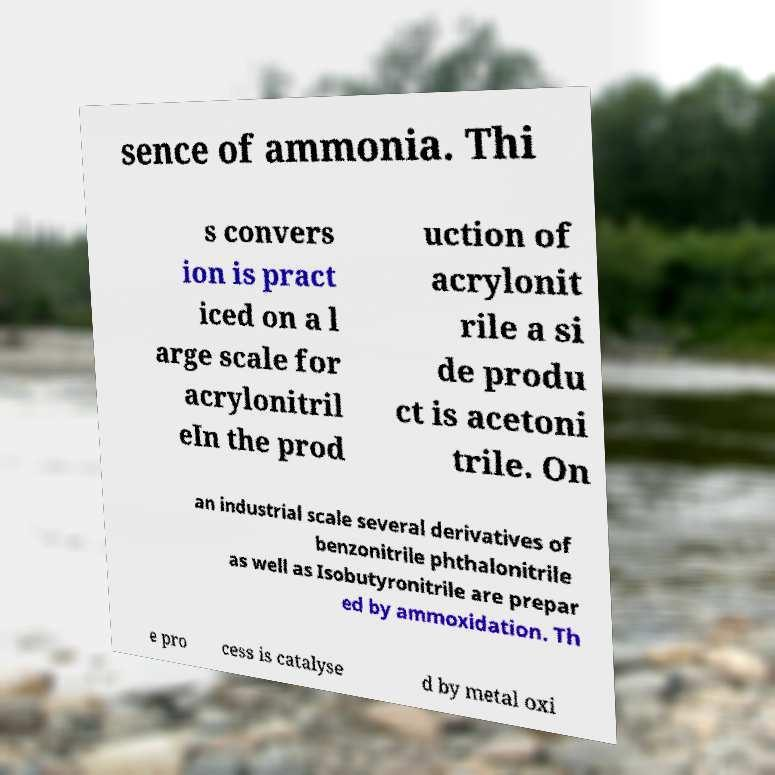Please read and relay the text visible in this image. What does it say? sence of ammonia. Thi s convers ion is pract iced on a l arge scale for acrylonitril eIn the prod uction of acrylonit rile a si de produ ct is acetoni trile. On an industrial scale several derivatives of benzonitrile phthalonitrile as well as Isobutyronitrile are prepar ed by ammoxidation. Th e pro cess is catalyse d by metal oxi 